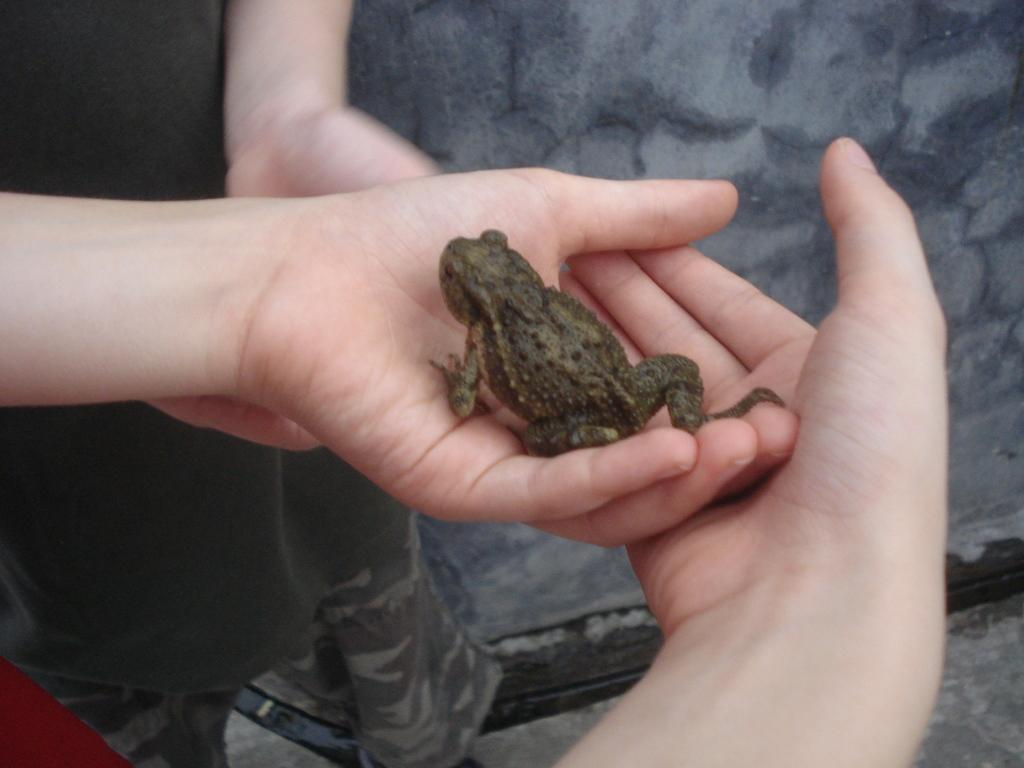What is on the person's hand in the image? There is a frog on the person's hand in the image. Can you describe the other person in the image? There is another person standing in the image. What can be seen in the background of the image? There is a wall visible in the background of the image. What type of alarm is going off in the image? There is no alarm going off in the image. What facial expression does the person holding the frog have? The image does not show the person's face, so their facial expression cannot be determined. 